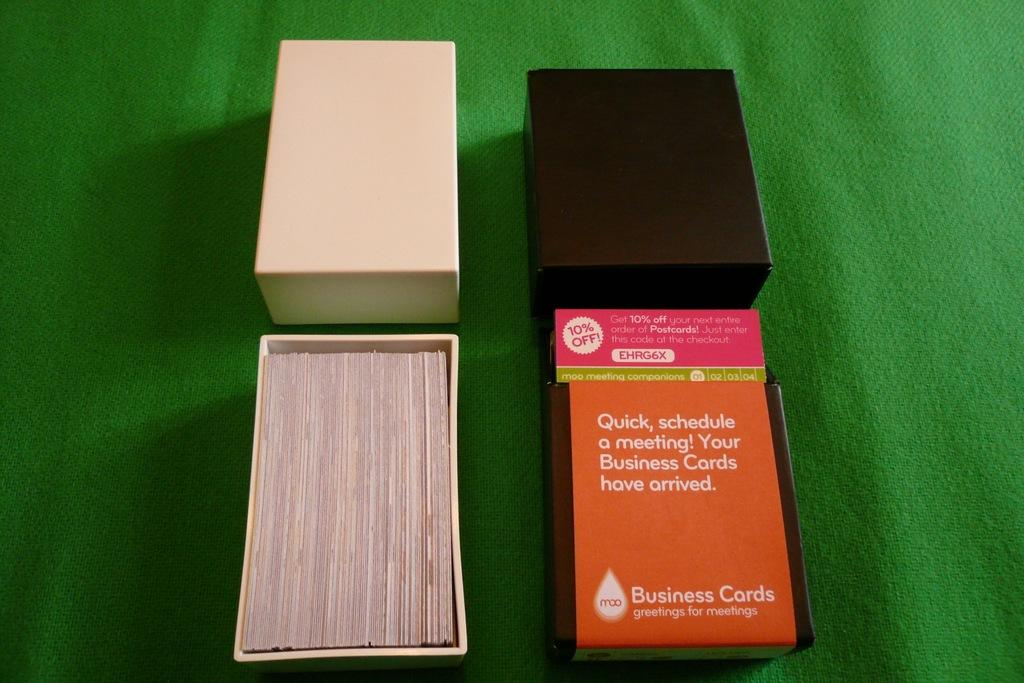<image>
Share a concise interpretation of the image provided. Business cards and the box that they came in. 